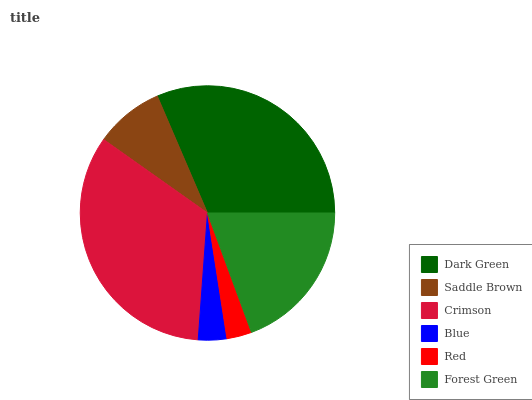Is Red the minimum?
Answer yes or no. Yes. Is Crimson the maximum?
Answer yes or no. Yes. Is Saddle Brown the minimum?
Answer yes or no. No. Is Saddle Brown the maximum?
Answer yes or no. No. Is Dark Green greater than Saddle Brown?
Answer yes or no. Yes. Is Saddle Brown less than Dark Green?
Answer yes or no. Yes. Is Saddle Brown greater than Dark Green?
Answer yes or no. No. Is Dark Green less than Saddle Brown?
Answer yes or no. No. Is Forest Green the high median?
Answer yes or no. Yes. Is Saddle Brown the low median?
Answer yes or no. Yes. Is Saddle Brown the high median?
Answer yes or no. No. Is Dark Green the low median?
Answer yes or no. No. 